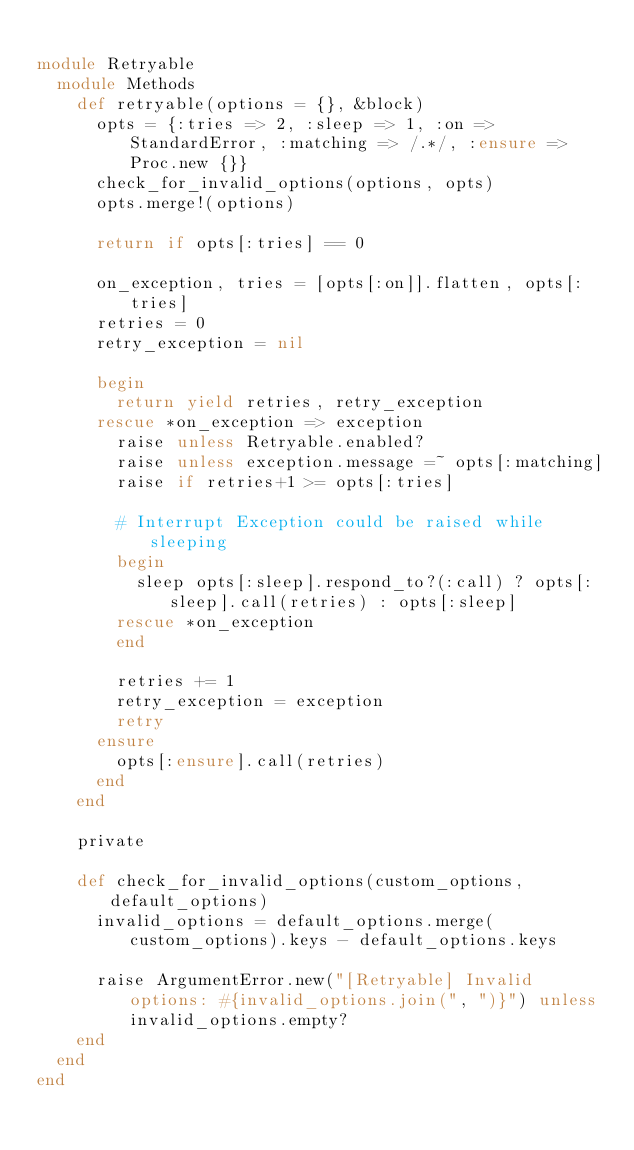Convert code to text. <code><loc_0><loc_0><loc_500><loc_500><_Ruby_>
module Retryable
  module Methods
    def retryable(options = {}, &block)
      opts = {:tries => 2, :sleep => 1, :on => StandardError, :matching => /.*/, :ensure => Proc.new {}}
      check_for_invalid_options(options, opts)
      opts.merge!(options)

      return if opts[:tries] == 0

      on_exception, tries = [opts[:on]].flatten, opts[:tries]
      retries = 0
      retry_exception = nil

      begin
        return yield retries, retry_exception
      rescue *on_exception => exception
        raise unless Retryable.enabled?
        raise unless exception.message =~ opts[:matching]
        raise if retries+1 >= opts[:tries]

        # Interrupt Exception could be raised while sleeping
        begin
          sleep opts[:sleep].respond_to?(:call) ? opts[:sleep].call(retries) : opts[:sleep]
        rescue *on_exception
        end

        retries += 1
        retry_exception = exception
        retry
      ensure
        opts[:ensure].call(retries)
      end
    end

    private

    def check_for_invalid_options(custom_options, default_options)
      invalid_options = default_options.merge(custom_options).keys - default_options.keys

      raise ArgumentError.new("[Retryable] Invalid options: #{invalid_options.join(", ")}") unless invalid_options.empty?
    end
  end
end
</code> 